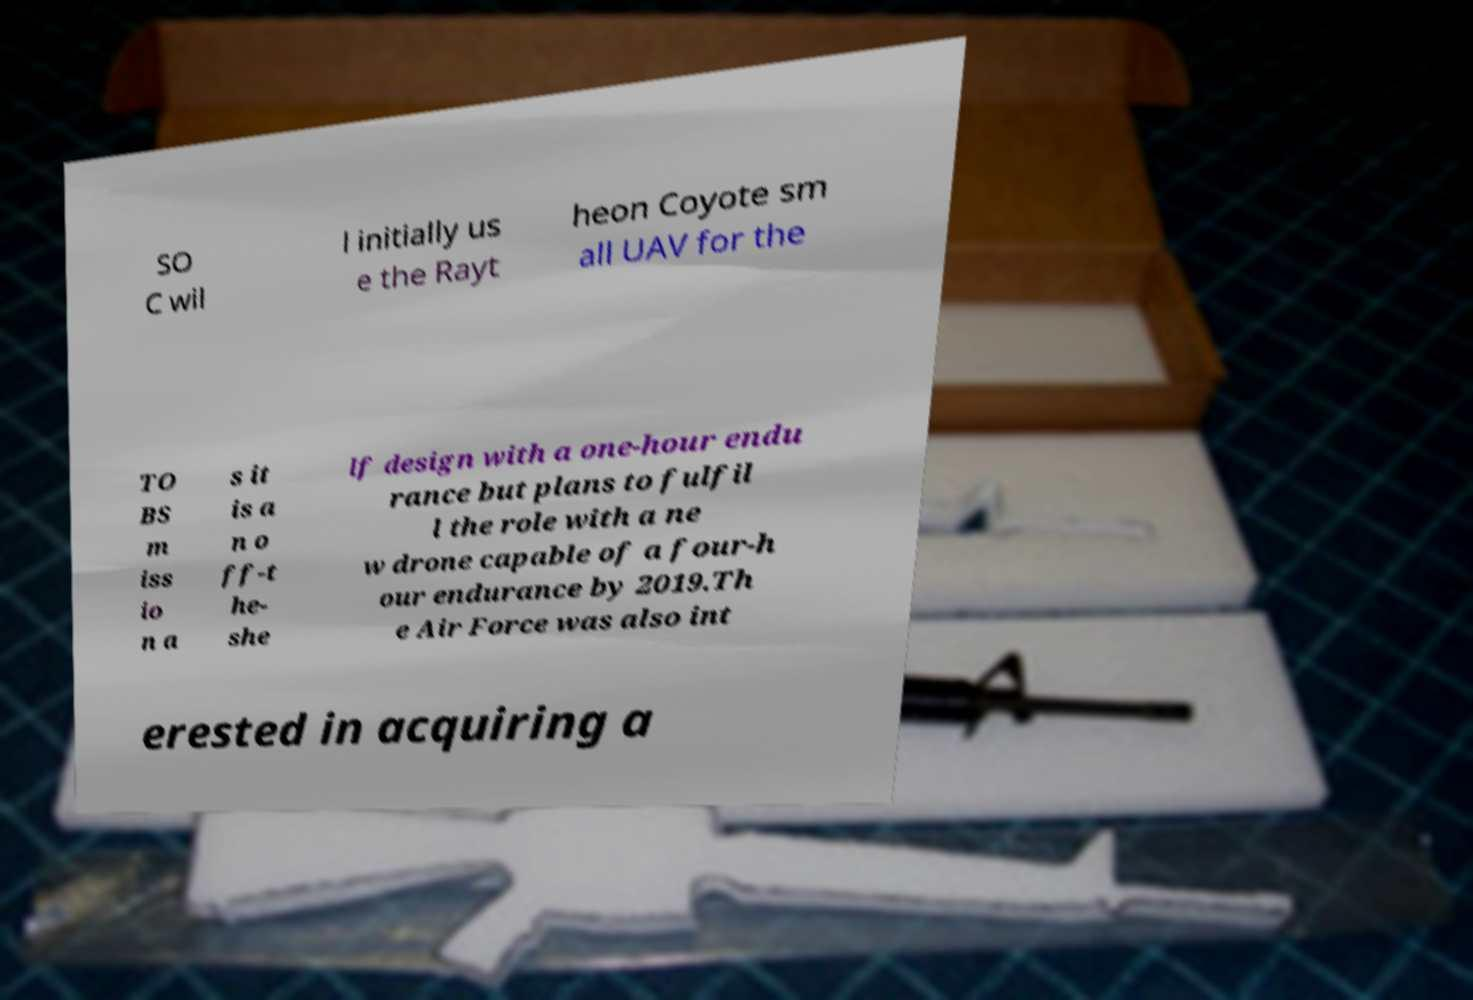There's text embedded in this image that I need extracted. Can you transcribe it verbatim? SO C wil l initially us e the Rayt heon Coyote sm all UAV for the TO BS m iss io n a s it is a n o ff-t he- she lf design with a one-hour endu rance but plans to fulfil l the role with a ne w drone capable of a four-h our endurance by 2019.Th e Air Force was also int erested in acquiring a 